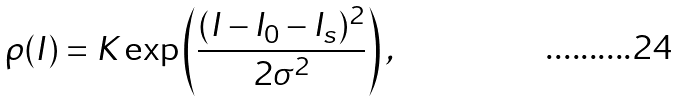Convert formula to latex. <formula><loc_0><loc_0><loc_500><loc_500>\rho ( I ) = K \exp \left ( \frac { ( I - I _ { 0 } - I _ { s } ) ^ { 2 } } { 2 \sigma ^ { 2 } } \right ) ,</formula> 